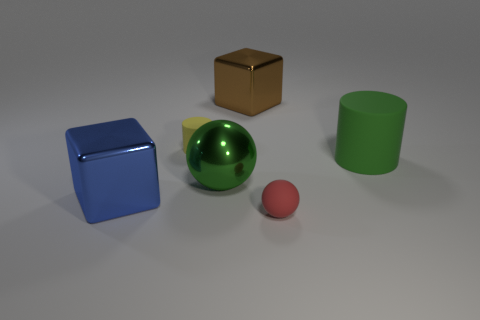Add 3 large blocks. How many objects exist? 9 Subtract all balls. How many objects are left? 4 Subtract 0 red cubes. How many objects are left? 6 Subtract all matte cylinders. Subtract all small red metal spheres. How many objects are left? 4 Add 4 yellow matte things. How many yellow matte things are left? 5 Add 1 big green matte things. How many big green matte things exist? 2 